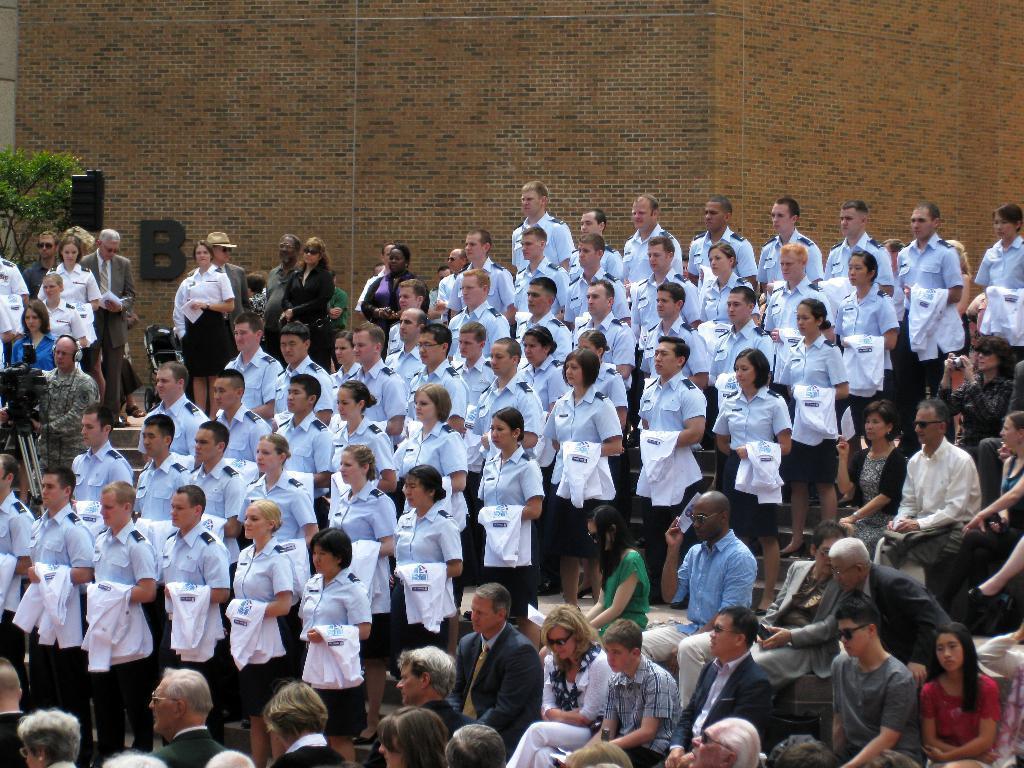Please provide a concise description of this image. In this image we can see a group of people wearing uniforms and white shirt in their hand are standing on the staircase. To the right side of the image we can see group of persons sitting. On the left side of the image we can see a person wearing headphones and holding a camera in his hand. In the background, we can see a tree. 